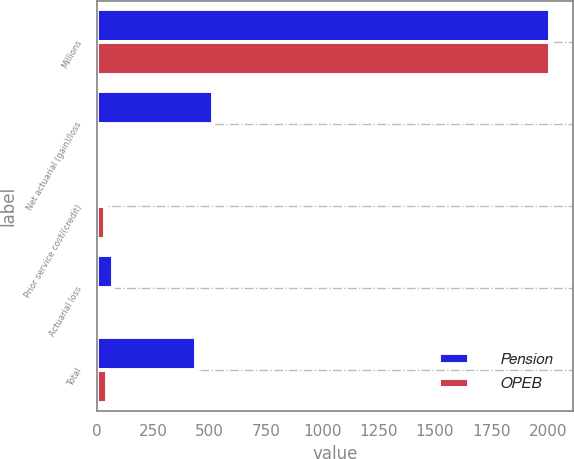Convert chart. <chart><loc_0><loc_0><loc_500><loc_500><stacked_bar_chart><ecel><fcel>Millions<fcel>Net actuarial (gain)/loss<fcel>Prior service cost/(credit)<fcel>Actuarial loss<fcel>Total<nl><fcel>Pension<fcel>2011<fcel>515<fcel>2<fcel>71<fcel>442<nl><fcel>OPEB<fcel>2011<fcel>14<fcel>34<fcel>11<fcel>47<nl></chart> 